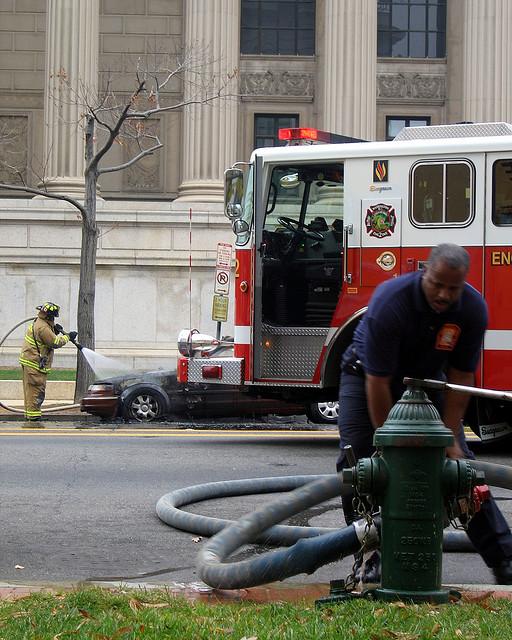What do the hoses carry?
Keep it brief. Water. What seems to have caught on fire?
Short answer required. Car. Does the fire truck have a door open?
Give a very brief answer. Yes. 